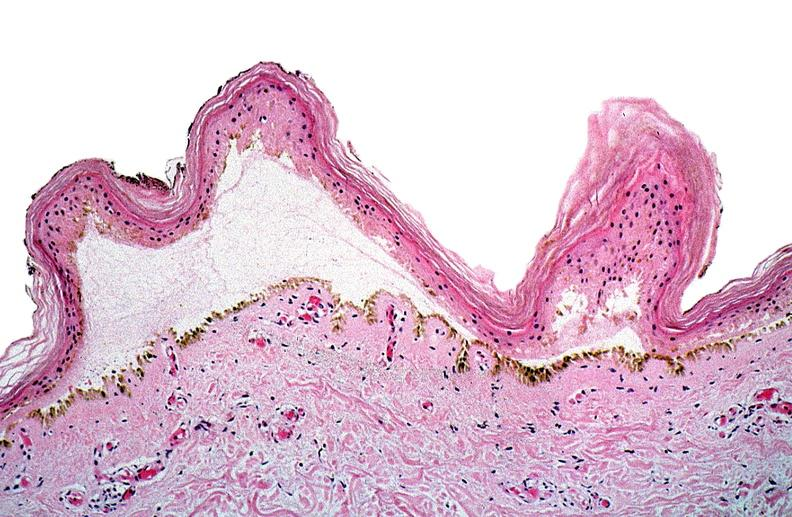does larynx show thermal burned skin?
Answer the question using a single word or phrase. No 